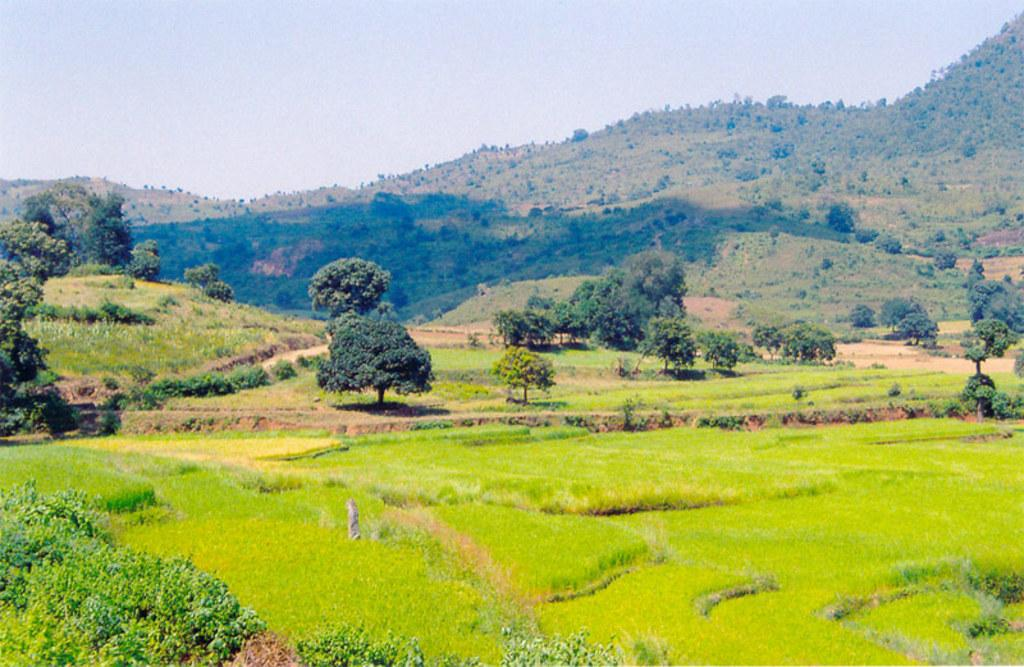What can be seen in the foreground of the image? There are farming fields, plants, and trees in the foreground of the image. What type of natural features are visible in the distance? There are mountains visible in the image. What part of the natural environment is visible in the image? The sky is visible in the image. How many desks can be seen in the image? There are no desks present in the image. What color are the eyes of the trees in the image? Trees do not have eyes, so this question cannot be answered. 